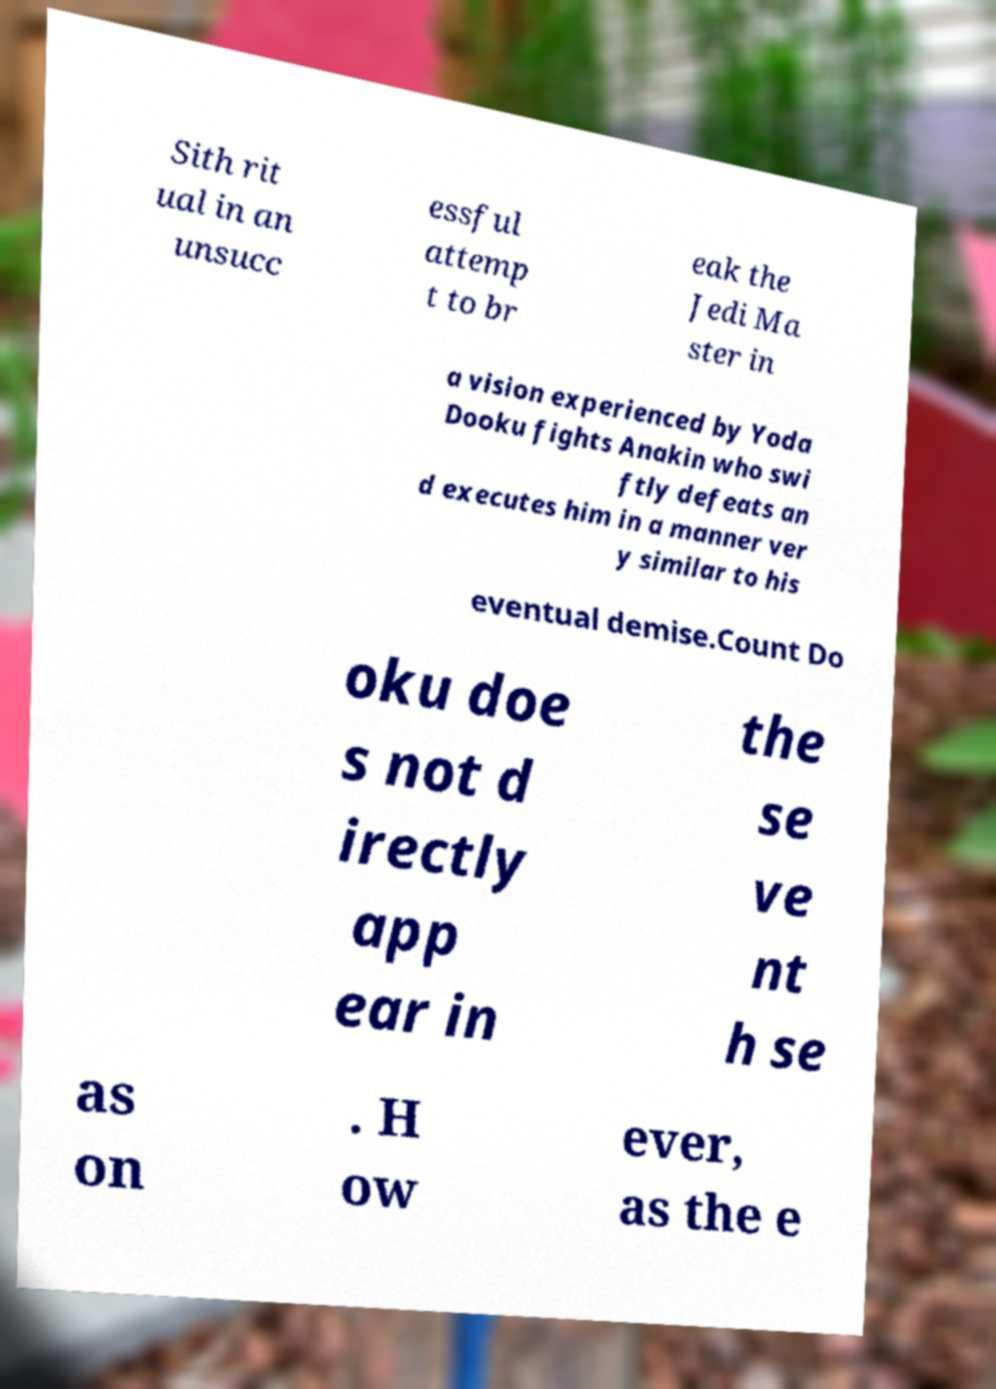What messages or text are displayed in this image? I need them in a readable, typed format. Sith rit ual in an unsucc essful attemp t to br eak the Jedi Ma ster in a vision experienced by Yoda Dooku fights Anakin who swi ftly defeats an d executes him in a manner ver y similar to his eventual demise.Count Do oku doe s not d irectly app ear in the se ve nt h se as on . H ow ever, as the e 